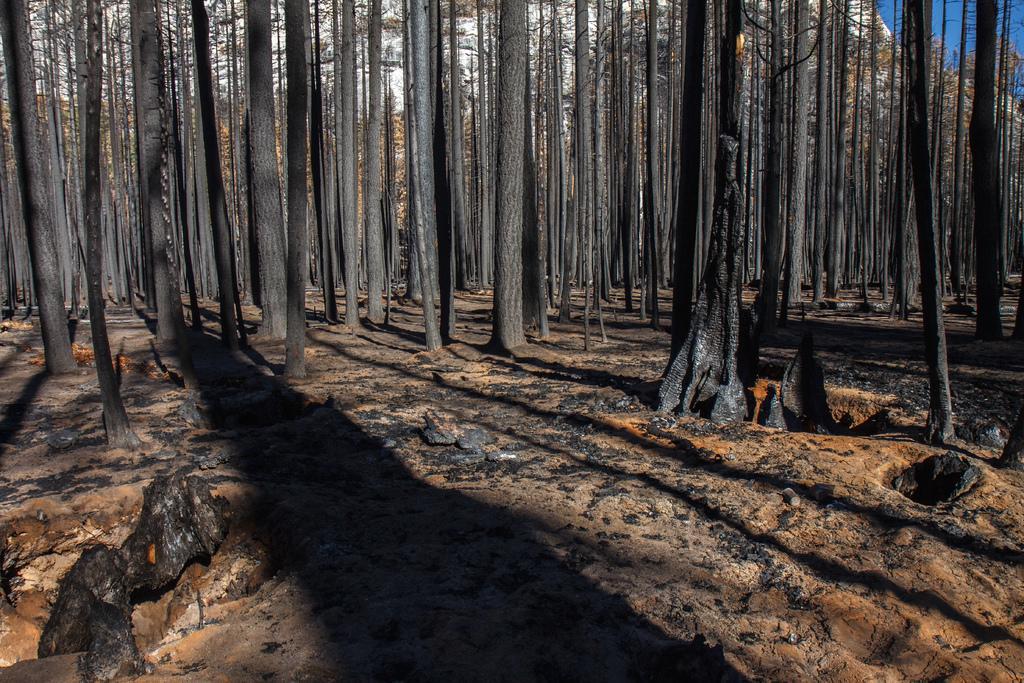Can you describe this image briefly? In the foreground of this image, there are tree trunks and in the background right, there is the sky. 